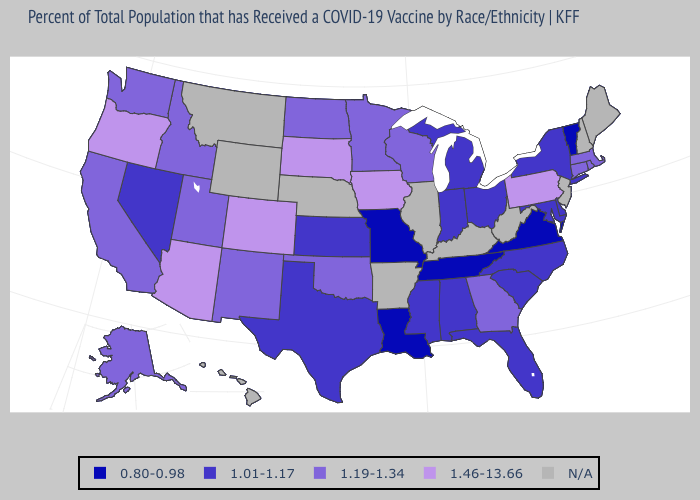What is the value of Maryland?
Be succinct. 1.01-1.17. What is the value of Kansas?
Write a very short answer. 1.01-1.17. What is the highest value in the West ?
Short answer required. 1.46-13.66. Does Missouri have the lowest value in the MidWest?
Give a very brief answer. Yes. Name the states that have a value in the range 1.19-1.34?
Write a very short answer. Alaska, California, Connecticut, Georgia, Idaho, Massachusetts, Minnesota, New Mexico, North Dakota, Oklahoma, Rhode Island, Utah, Washington, Wisconsin. Which states hav the highest value in the South?
Write a very short answer. Georgia, Oklahoma. Does Nevada have the lowest value in the West?
Short answer required. Yes. Name the states that have a value in the range N/A?
Be succinct. Arkansas, Hawaii, Illinois, Kentucky, Maine, Montana, Nebraska, New Hampshire, New Jersey, West Virginia, Wyoming. What is the value of Washington?
Give a very brief answer. 1.19-1.34. What is the lowest value in the MidWest?
Concise answer only. 0.80-0.98. Among the states that border Nevada , which have the lowest value?
Give a very brief answer. California, Idaho, Utah. What is the value of North Carolina?
Be succinct. 1.01-1.17. 